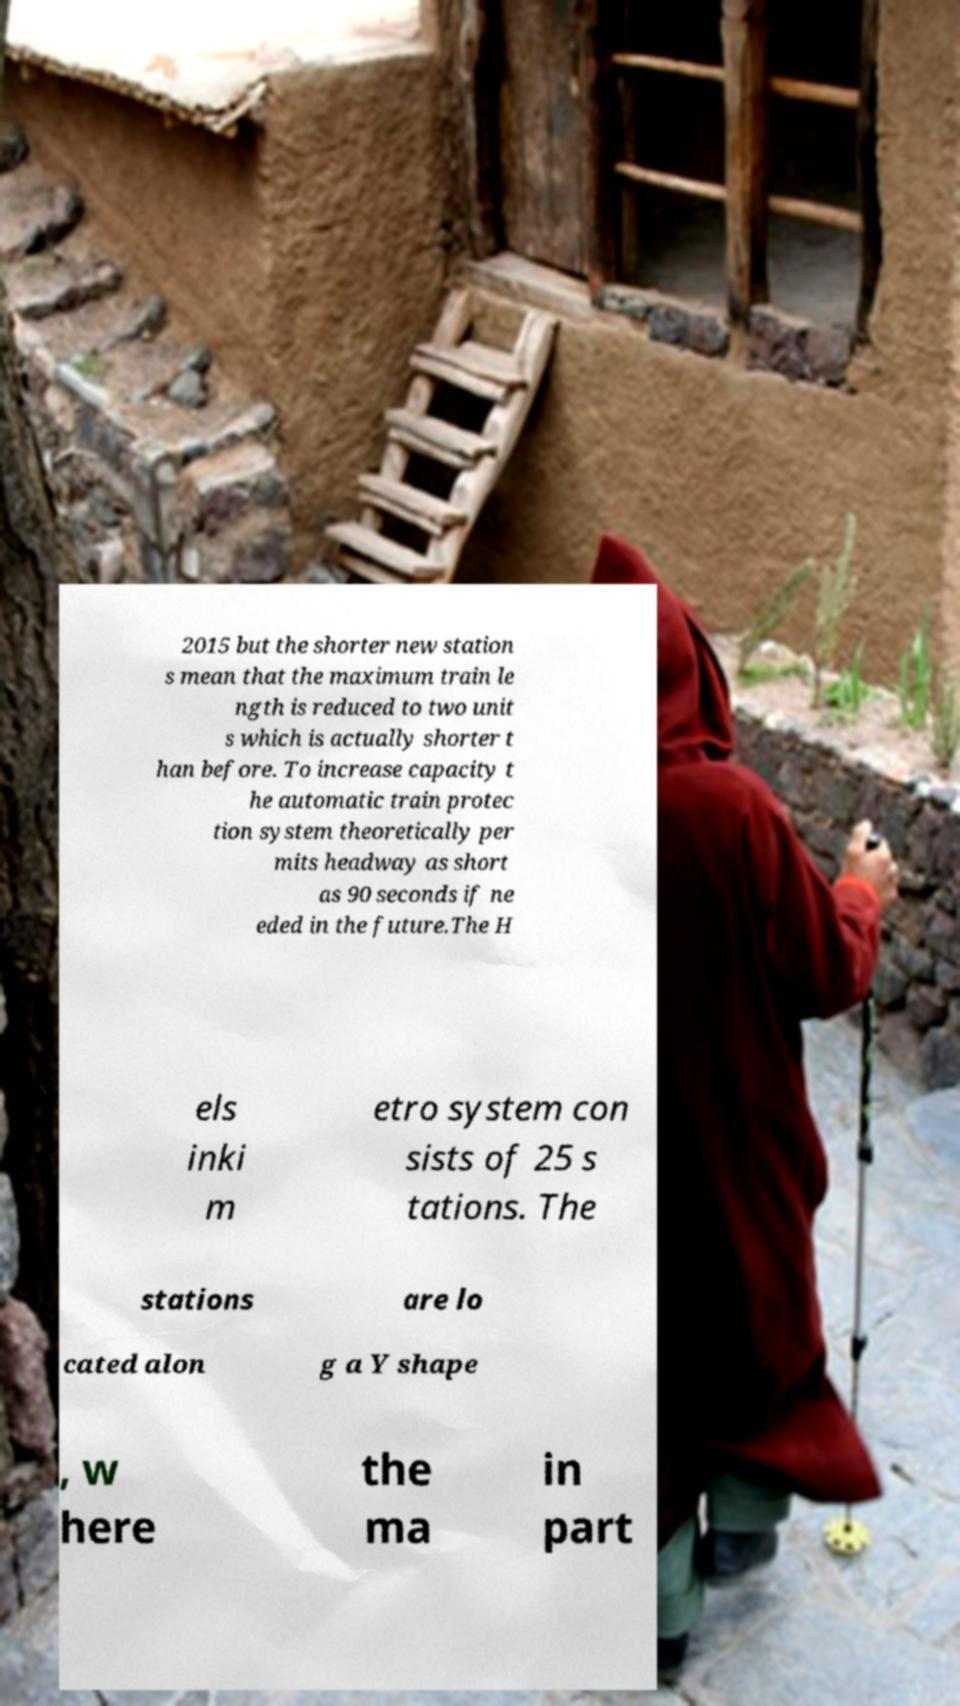For documentation purposes, I need the text within this image transcribed. Could you provide that? 2015 but the shorter new station s mean that the maximum train le ngth is reduced to two unit s which is actually shorter t han before. To increase capacity t he automatic train protec tion system theoretically per mits headway as short as 90 seconds if ne eded in the future.The H els inki m etro system con sists of 25 s tations. The stations are lo cated alon g a Y shape , w here the ma in part 